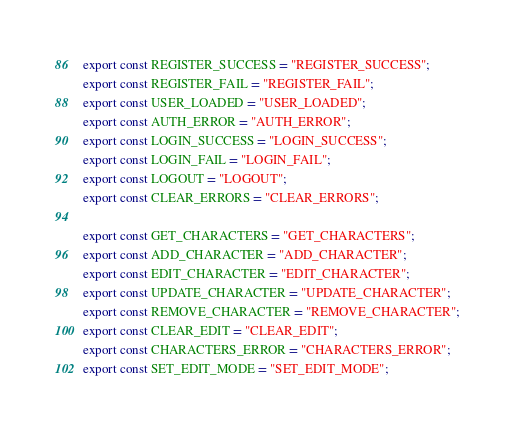Convert code to text. <code><loc_0><loc_0><loc_500><loc_500><_JavaScript_>export const REGISTER_SUCCESS = "REGISTER_SUCCESS";
export const REGISTER_FAIL = "REGISTER_FAIL";
export const USER_LOADED = "USER_LOADED";
export const AUTH_ERROR = "AUTH_ERROR";
export const LOGIN_SUCCESS = "LOGIN_SUCCESS";
export const LOGIN_FAIL = "LOGIN_FAIL";
export const LOGOUT = "LOGOUT";
export const CLEAR_ERRORS = "CLEAR_ERRORS";

export const GET_CHARACTERS = "GET_CHARACTERS";
export const ADD_CHARACTER = "ADD_CHARACTER";
export const EDIT_CHARACTER = "EDIT_CHARACTER";
export const UPDATE_CHARACTER = "UPDATE_CHARACTER";
export const REMOVE_CHARACTER = "REMOVE_CHARACTER";
export const CLEAR_EDIT = "CLEAR_EDIT";
export const CHARACTERS_ERROR = "CHARACTERS_ERROR";
export const SET_EDIT_MODE = "SET_EDIT_MODE";
</code> 